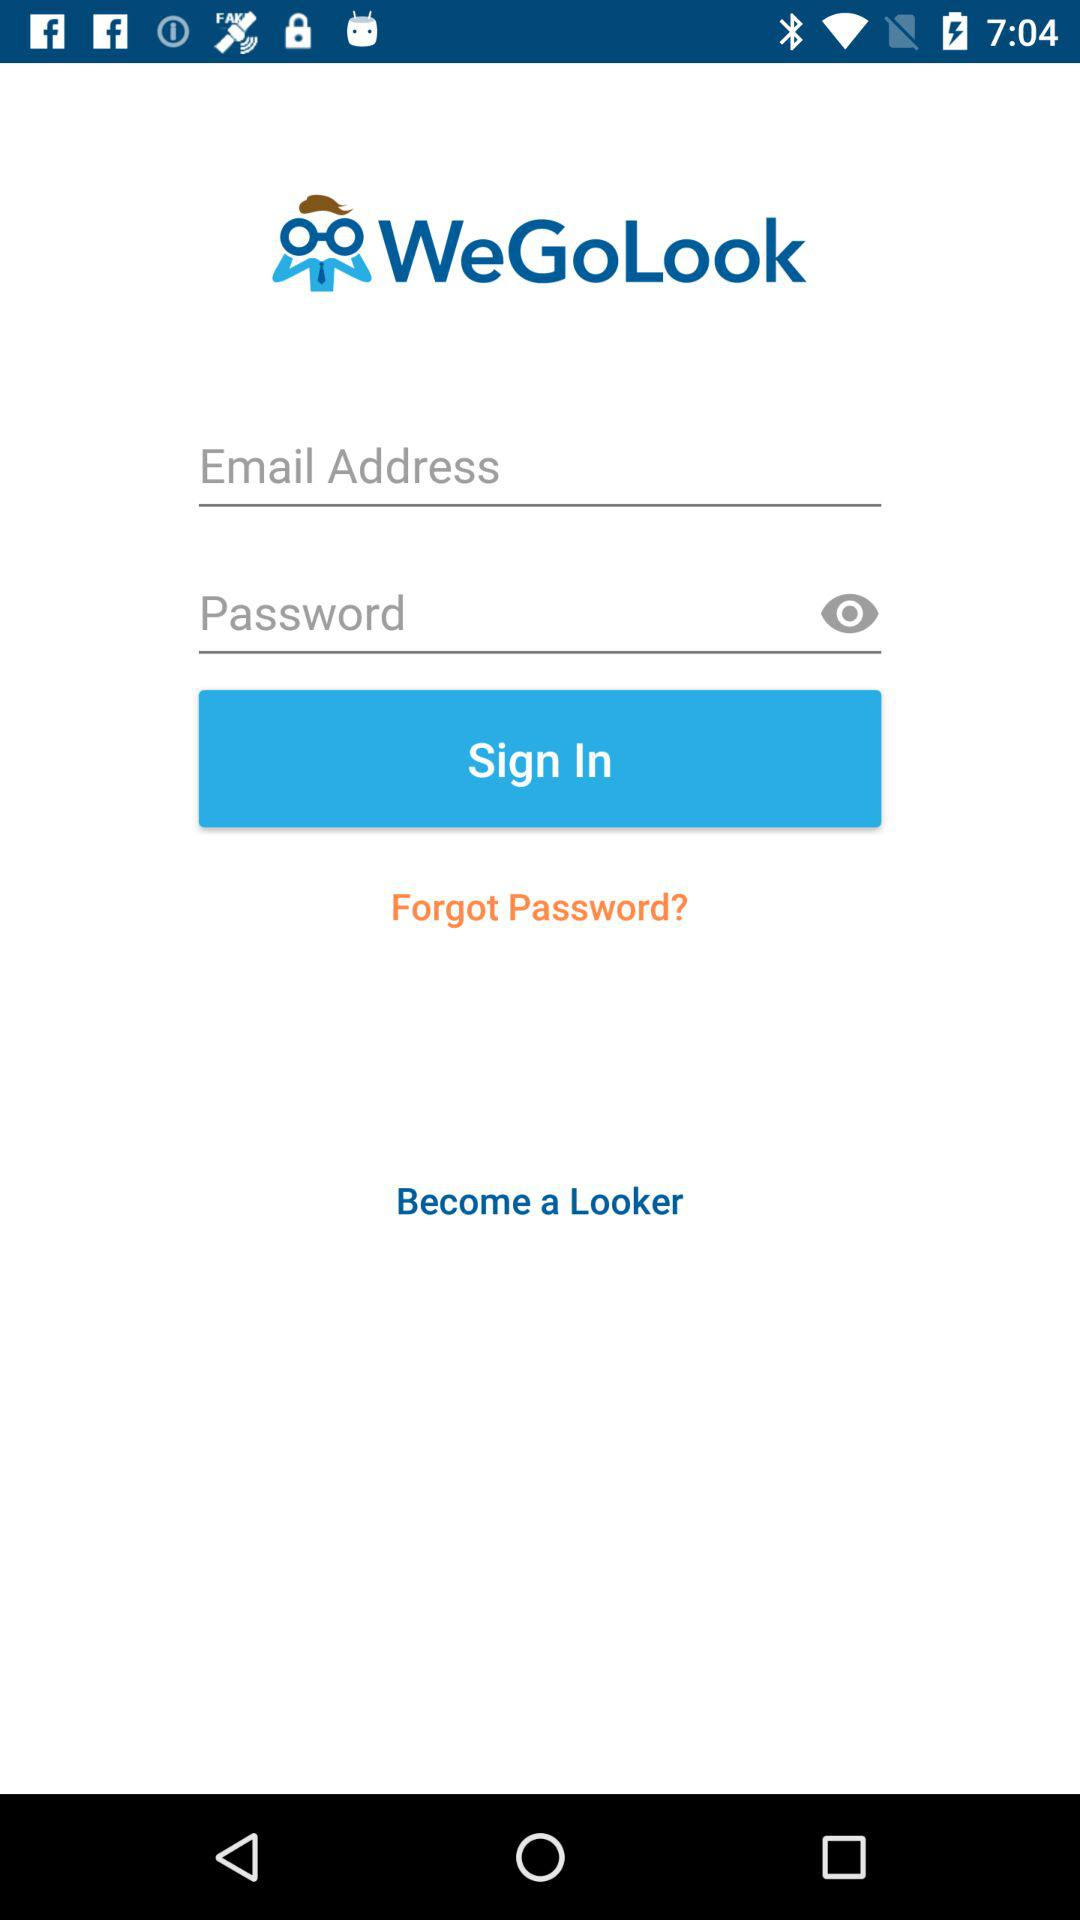Can we reset password?
When the provided information is insufficient, respond with <no answer>. <no answer> 